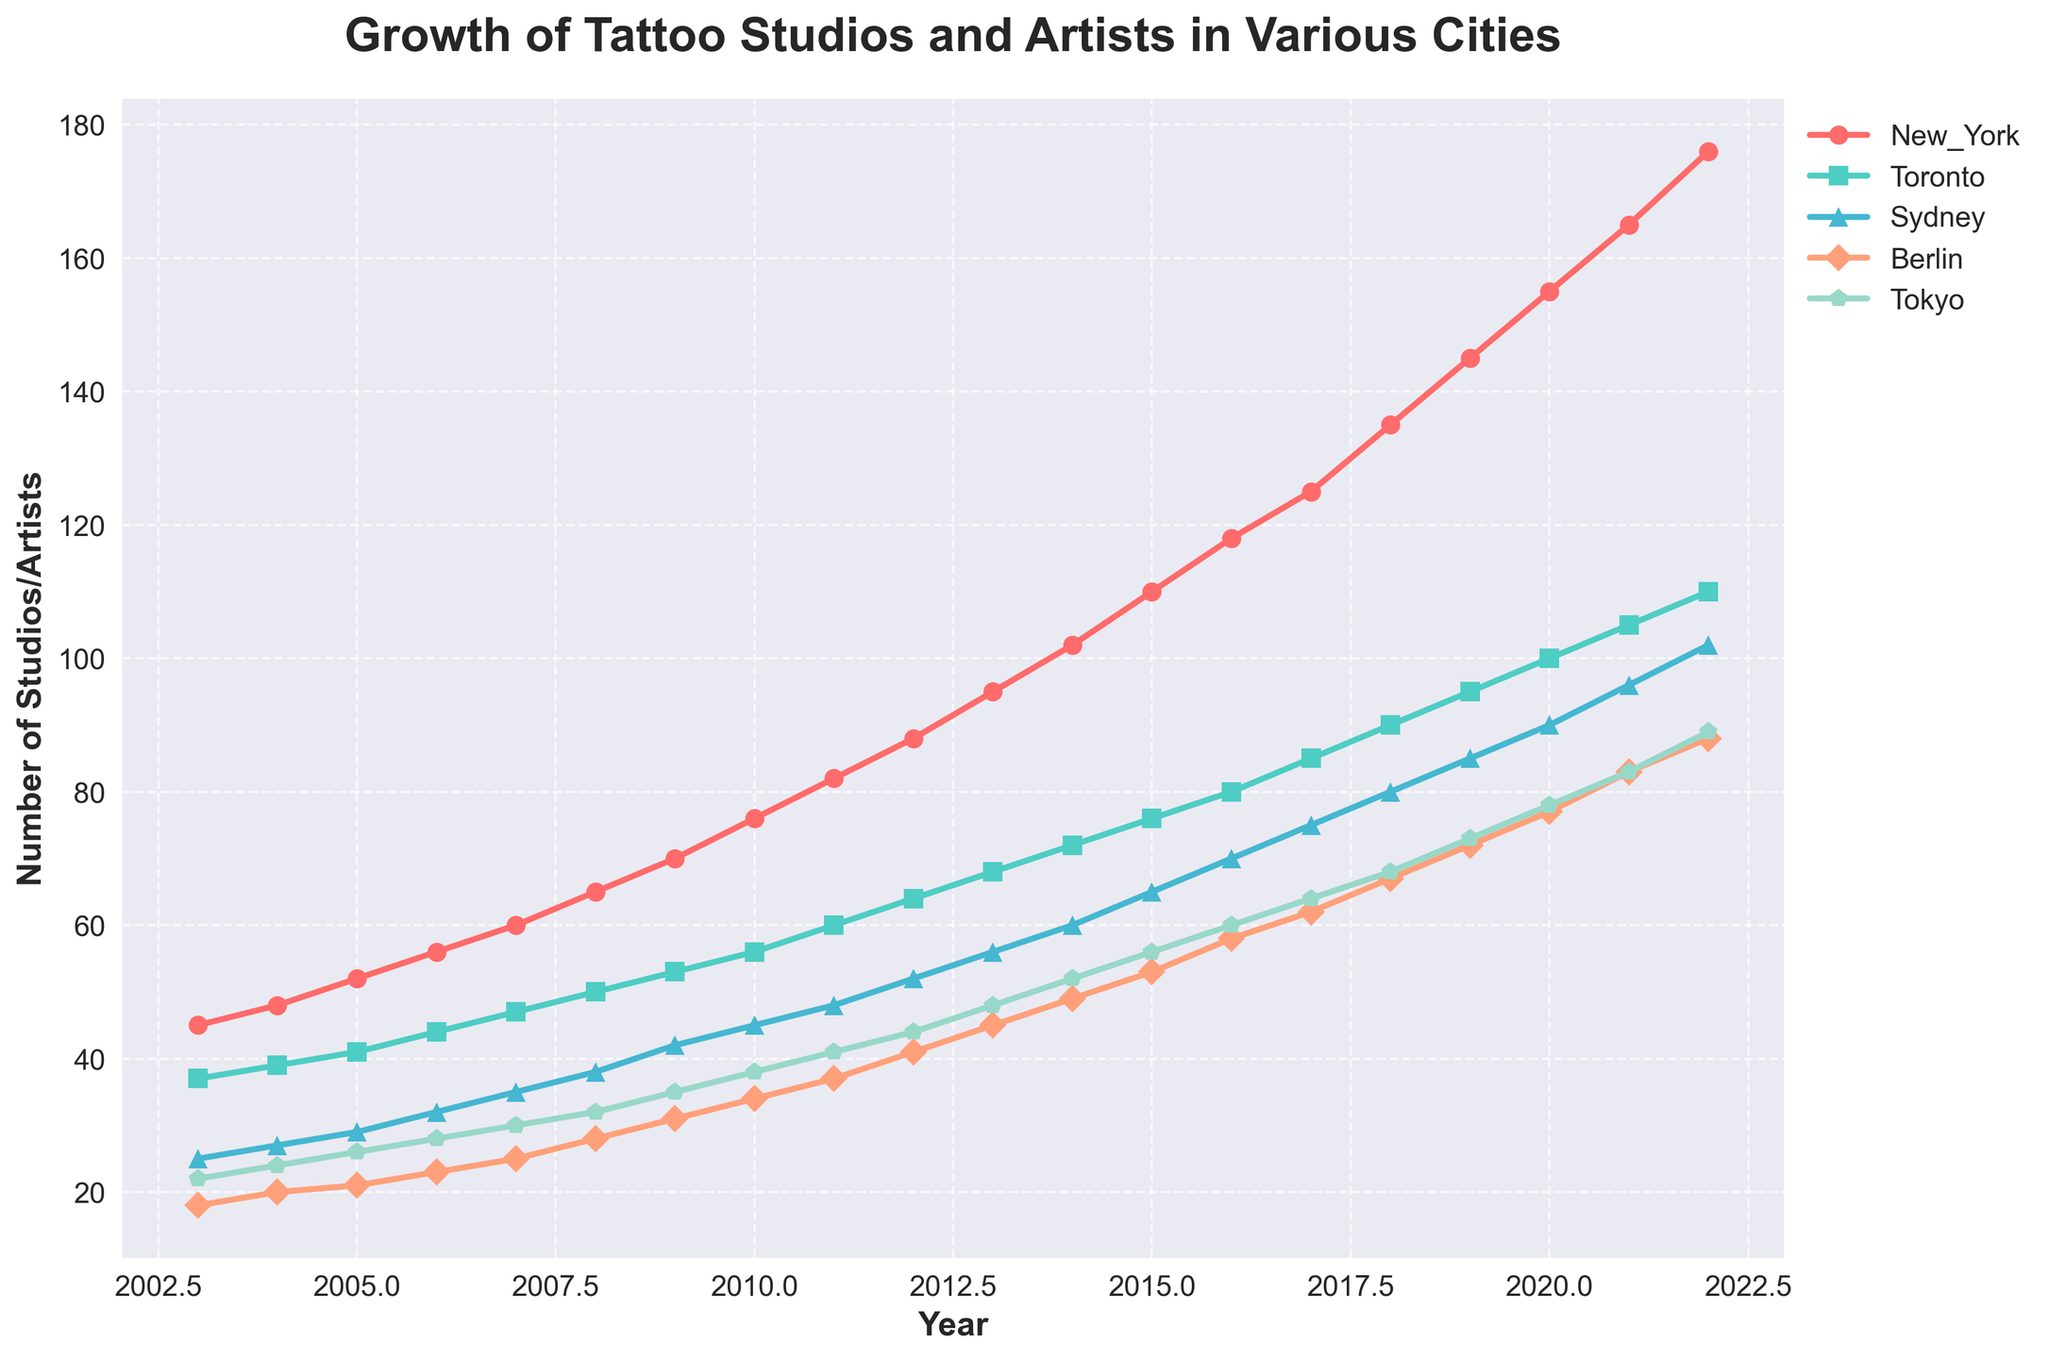What is the title of the figure? The title of the figure is usually displayed at the top and summarizes the content briefly. Here, it indicates the main subject of the plot.
Answer: Growth of Tattoo Studios and Artists in Various Cities What years are displayed on the x-axis? The x-axis shows the period over which the data was collected. By checking the x-axis, we can identify the range of years plotted.
Answer: 2003 to 2022 Which city had the highest number of studios/artists in 2022? To find this, we look at the data points for 2022 on the y-axis for each city and compare them. New York has the highest value.
Answer: New York What is the number of studios/artists in Tokyo in 2015? Locate the year 2015 on the x-axis and then check the corresponding data point for Tokyo to find this number.
Answer: 56 Between which two consecutive years did Berlin observe the highest increase in the number of studios/artists? Find the difference in values for Berlin between each pair of consecutive years and identify the pair with the greatest difference.
Answer: 2019 to 2020 How many total studios/artists were recorded in New York from 2020 to 2022? Sum the values for New York from the years 2020, 2021, and 2022. (155 + 165 + 176 = 496)
Answer: 496 Which city showed the most consistent growth over the years? Assess the smoothness and steadiness of each city's line on the plot. Toronto shows steady and consistent growth.
Answer: Toronto How does the growth trend in Sydney compare between 2003 to 2012 and 2013 to 2022? Calculate the rate of increase in the number of studios/artists for these two periods and compare them. The slope in the first period (2003-2012) is less steep compared to the second period (2013-2022).
Answer: Faster growth from 2013 to 2022 What's the average number of studios/artists in Tokyo across all years? Sum the yearly values for Tokyo and divide by the number of years (20). (22 + 24 + 26 + 28 + 30 + 32 + 35 + 38 + 41 + 44 + 48 + 52 + 56 + 60 + 64 + 68 + 73 + 78 + 83 + 89) / 20 = 49.4
Answer: 49.4 Which cities had fewer than 50 studios/artists in 2010? Check the data points for 2010 across all cities and identify those with values below 50.
Answer: Sydney, Berlin, Tokyo 